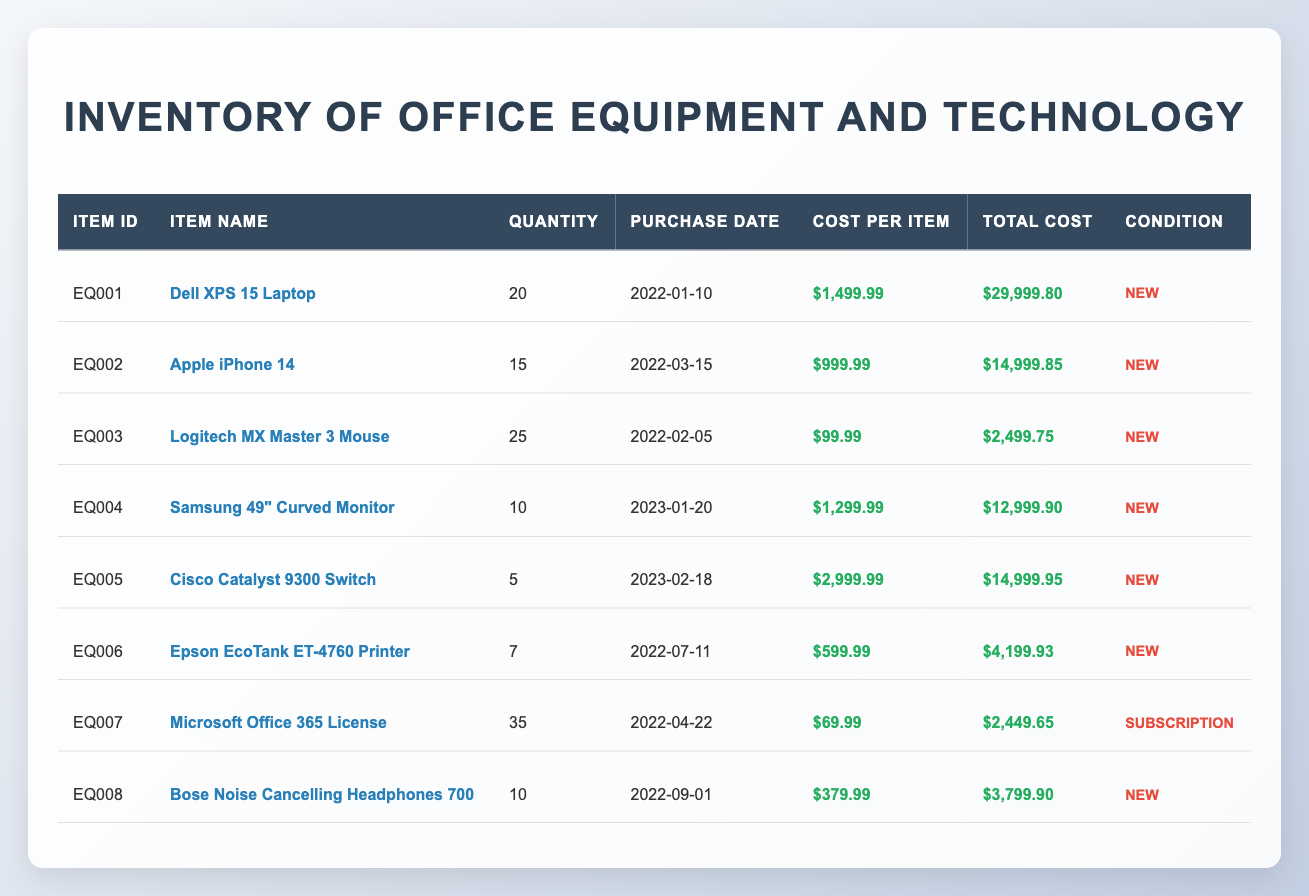What is the total quantity of laptops in the inventory? There are 20 Dell XPS 15 Laptops listed in the inventory. Thus, the total quantity of laptops is 20.
Answer: 20 What is the total cost of all the Cisco Catalyst 9300 Switches? The cost per item for the Cisco Catalyst 9300 Switch is $2999.99 and there are 5 units, so the total cost is calculated as 5 * 2999.99 = 14999.95.
Answer: 14999.95 Are all the items in the inventory in new condition? By examining the condition column, all listed items state "New" except for the Microsoft Office 365 License, which is a subscription. Therefore, not all items are in new condition.
Answer: No What is the average cost per item for all office equipment? To find the average cost per item, we need to calculate the total cost of all items and divide it by the total quantity. Summing the total costs gives us 29999.80 + 14999.85 + 2499.75 + 12999.90 + 14999.95 + 4199.93 + 2449.65 + 3799.90 = 74699.08. The total quantity is 20 + 15 + 25 + 10 + 5 + 7 + 35 + 10 = 127. Now, we calculate the average as 74699.08 / 127 ≈ 587.20.
Answer: 587.20 What is the difference in total cost between the Dell laptops and Apple iPhones? The total cost for the Dell XPS 15 Laptops is $29999.80, while for the Apple iPhone 14 it is $14999.85. The difference is calculated as 29999.80 - 14999.85 = 14999.95.
Answer: 14999.95 